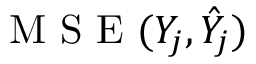<formula> <loc_0><loc_0><loc_500><loc_500>M S E ( Y _ { j } , \hat { Y } _ { j } )</formula> 